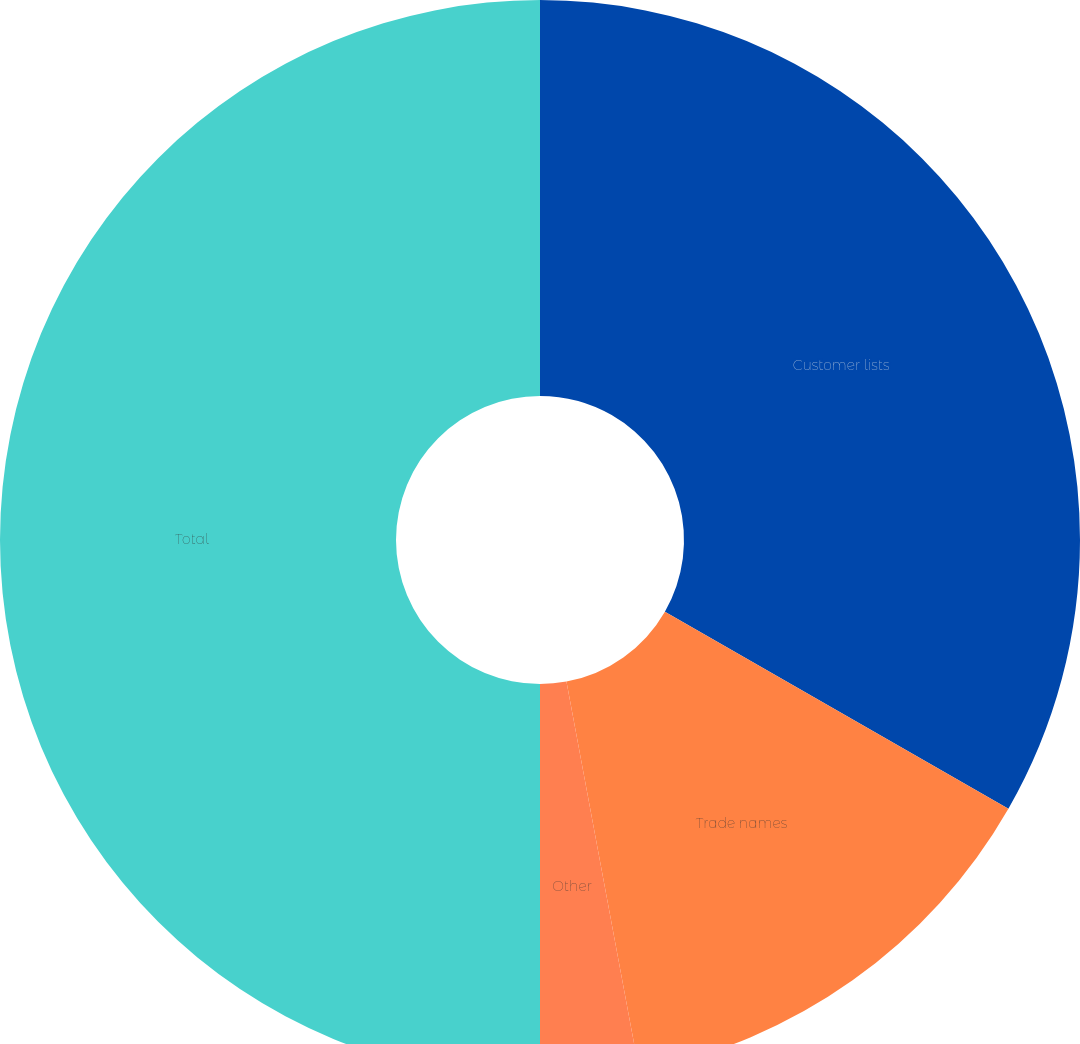Convert chart to OTSL. <chart><loc_0><loc_0><loc_500><loc_500><pie_chart><fcel>Customer lists<fcel>Trade names<fcel>Other<fcel>Total<nl><fcel>33.29%<fcel>13.77%<fcel>2.94%<fcel>50.0%<nl></chart> 